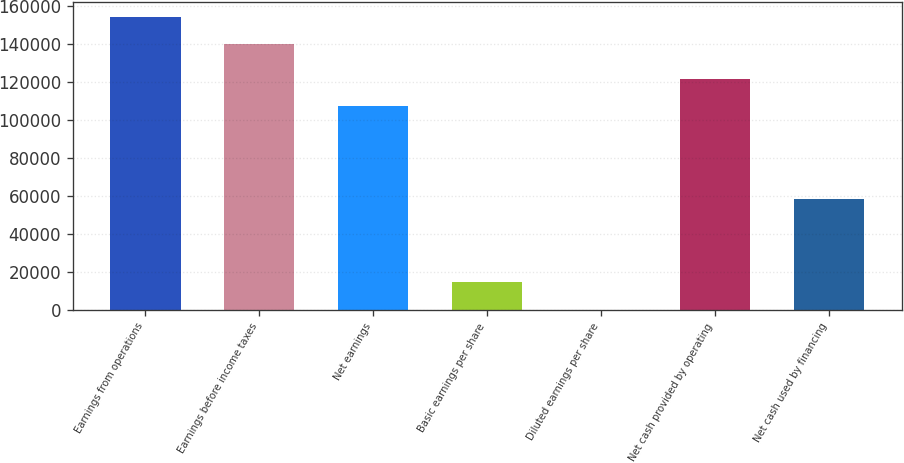Convert chart. <chart><loc_0><loc_0><loc_500><loc_500><bar_chart><fcel>Earnings from operations<fcel>Earnings before income taxes<fcel>Net earnings<fcel>Basic earnings per share<fcel>Diluted earnings per share<fcel>Net cash provided by operating<fcel>Net cash used by financing<nl><fcel>154453<fcel>140017<fcel>107178<fcel>14437.4<fcel>1.4<fcel>121614<fcel>58610<nl></chart> 